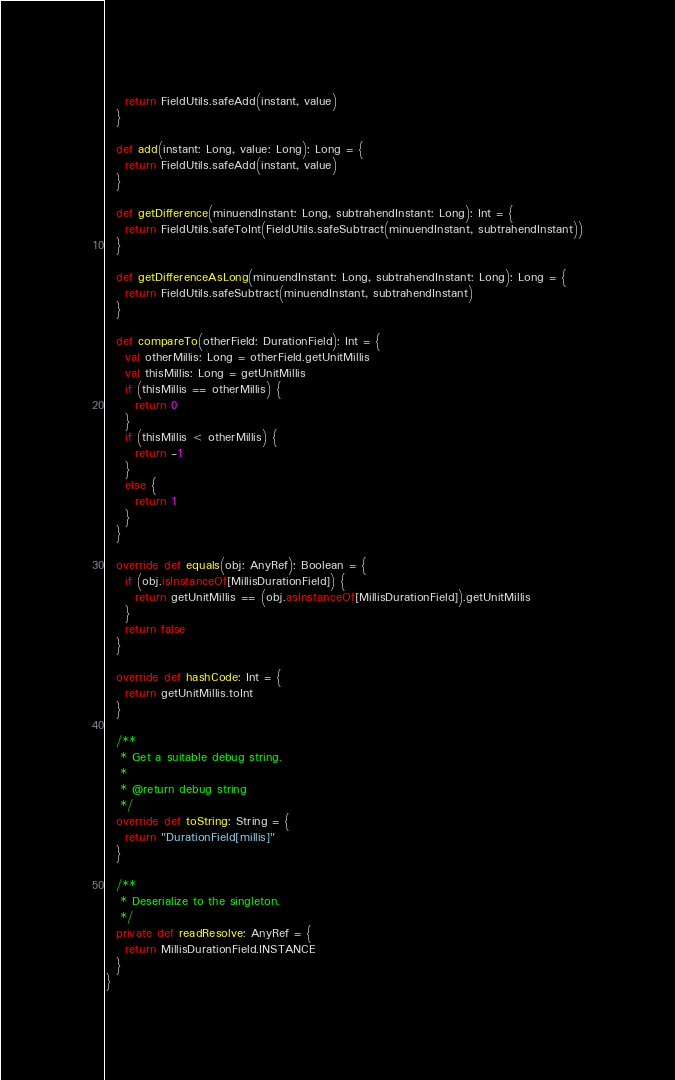Convert code to text. <code><loc_0><loc_0><loc_500><loc_500><_Scala_>    return FieldUtils.safeAdd(instant, value)
  }

  def add(instant: Long, value: Long): Long = {
    return FieldUtils.safeAdd(instant, value)
  }

  def getDifference(minuendInstant: Long, subtrahendInstant: Long): Int = {
    return FieldUtils.safeToInt(FieldUtils.safeSubtract(minuendInstant, subtrahendInstant))
  }

  def getDifferenceAsLong(minuendInstant: Long, subtrahendInstant: Long): Long = {
    return FieldUtils.safeSubtract(minuendInstant, subtrahendInstant)
  }

  def compareTo(otherField: DurationField): Int = {
    val otherMillis: Long = otherField.getUnitMillis
    val thisMillis: Long = getUnitMillis
    if (thisMillis == otherMillis) {
      return 0
    }
    if (thisMillis < otherMillis) {
      return -1
    }
    else {
      return 1
    }
  }

  override def equals(obj: AnyRef): Boolean = {
    if (obj.isInstanceOf[MillisDurationField]) {
      return getUnitMillis == (obj.asInstanceOf[MillisDurationField]).getUnitMillis
    }
    return false
  }

  override def hashCode: Int = {
    return getUnitMillis.toInt
  }

  /**
   * Get a suitable debug string.
   *
   * @return debug string
   */
  override def toString: String = {
    return "DurationField[millis]"
  }

  /**
   * Deserialize to the singleton.
   */
  private def readResolve: AnyRef = {
    return MillisDurationField.INSTANCE
  }
}</code> 